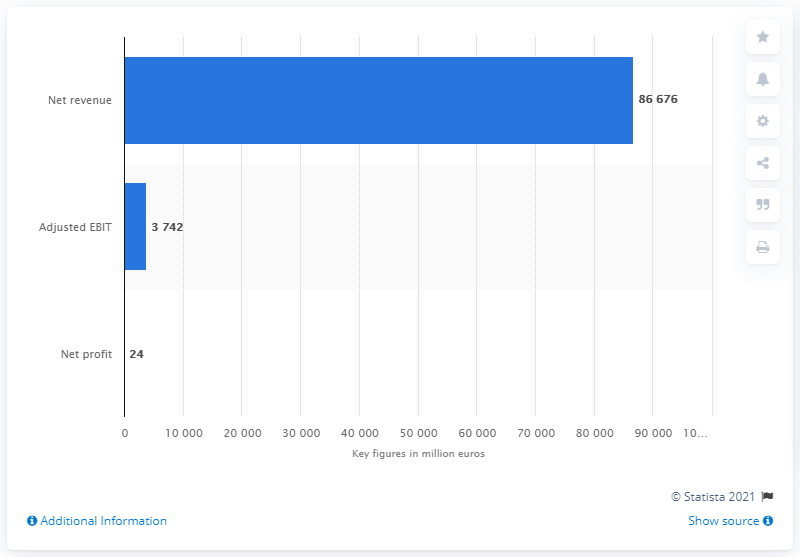Draw attention to some important aspects in this diagram. In 2020, Fiat Chrysler Automobiles reported a net profit of 24 billion dollars. 